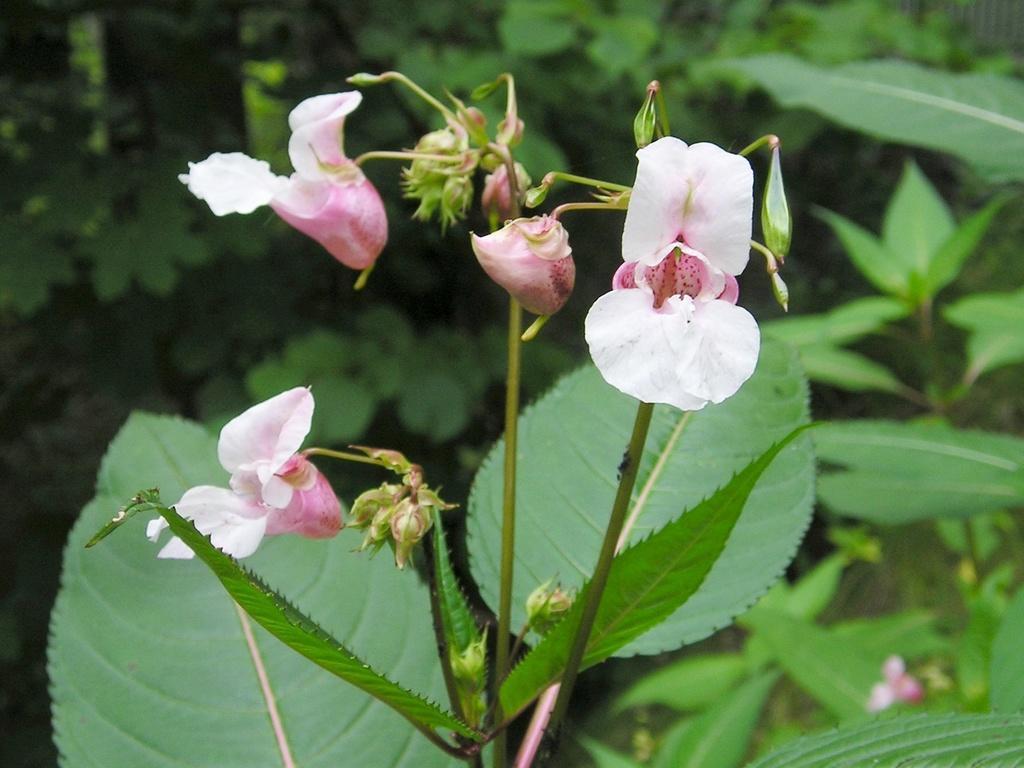Please provide a concise description of this image. In the center of the image there are plants and we can see flowers to it. 